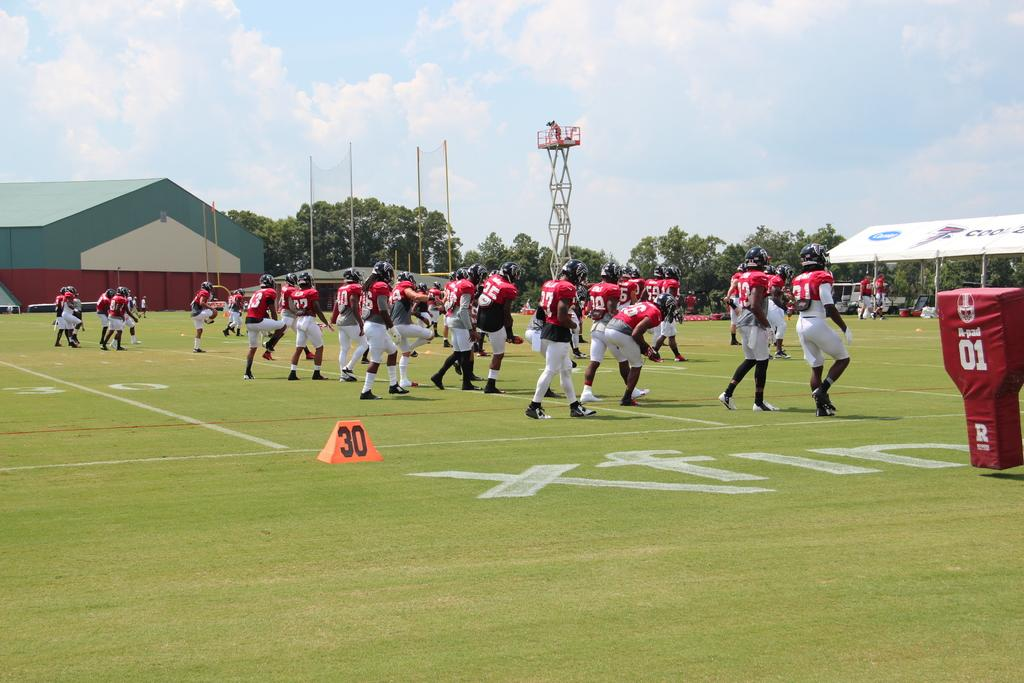Who or what is present in the image? There are people in the image. What can be seen in the background of the image? There are sheds, trees, poles, and the sky visible in the background of the image. What structure is present in the image? There is a tower in the image. Can you tell me how many times the parent waves in the image? There is no parent present in the image, so it is not possible to determine how many times they might wave. 